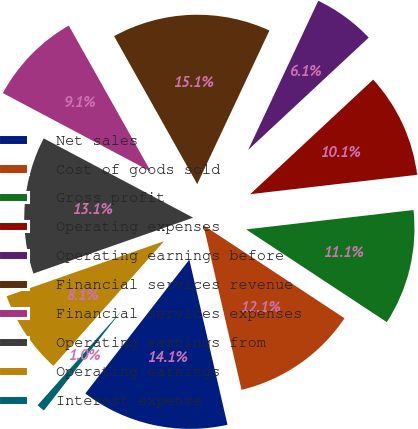Convert chart to OTSL. <chart><loc_0><loc_0><loc_500><loc_500><pie_chart><fcel>Net sales<fcel>Cost of goods sold<fcel>Gross profit<fcel>Operating expenses<fcel>Operating earnings before<fcel>Financial services revenue<fcel>Financial services expenses<fcel>Operating earnings from<fcel>Operating earnings<fcel>Interest expense<nl><fcel>14.13%<fcel>12.11%<fcel>11.11%<fcel>10.1%<fcel>6.07%<fcel>15.14%<fcel>9.09%<fcel>13.12%<fcel>8.09%<fcel>1.04%<nl></chart> 